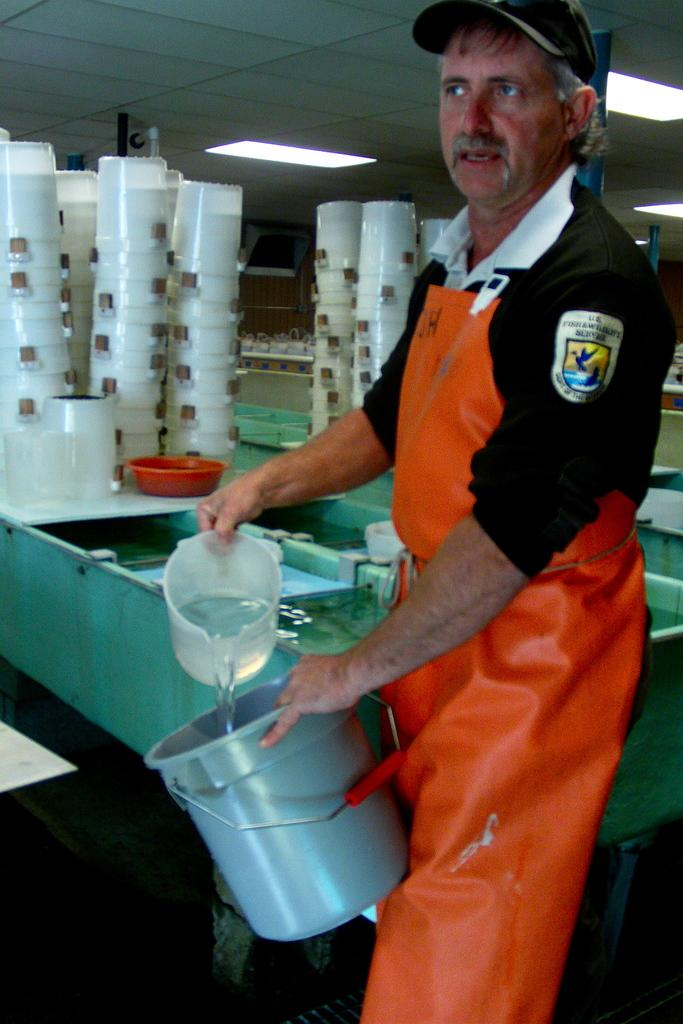What is the person in the center of the image holding? The person is holding a bucket and a mug. What else can be seen in the background of the image? There are mugs, water, a container, a light, and a wall visible in the background of the image. What type of verse can be heard recited by the cows in the image? There are no cows present in the image, so it is not possible to hear any verses recited by them. 